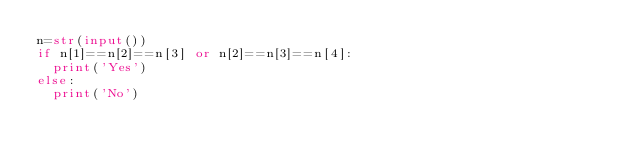Convert code to text. <code><loc_0><loc_0><loc_500><loc_500><_Python_>n=str(input())
if n[1]==n[2]==n[3] or n[2]==n[3]==n[4]:
  print('Yes')
else:
  print('No')</code> 